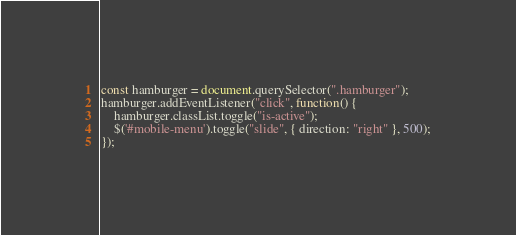<code> <loc_0><loc_0><loc_500><loc_500><_JavaScript_>

const hamburger = document.querySelector(".hamburger");
hamburger.addEventListener("click", function() {
    hamburger.classList.toggle("is-active");
    $('#mobile-menu').toggle("slide", { direction: "right" }, 500);
});

</code> 